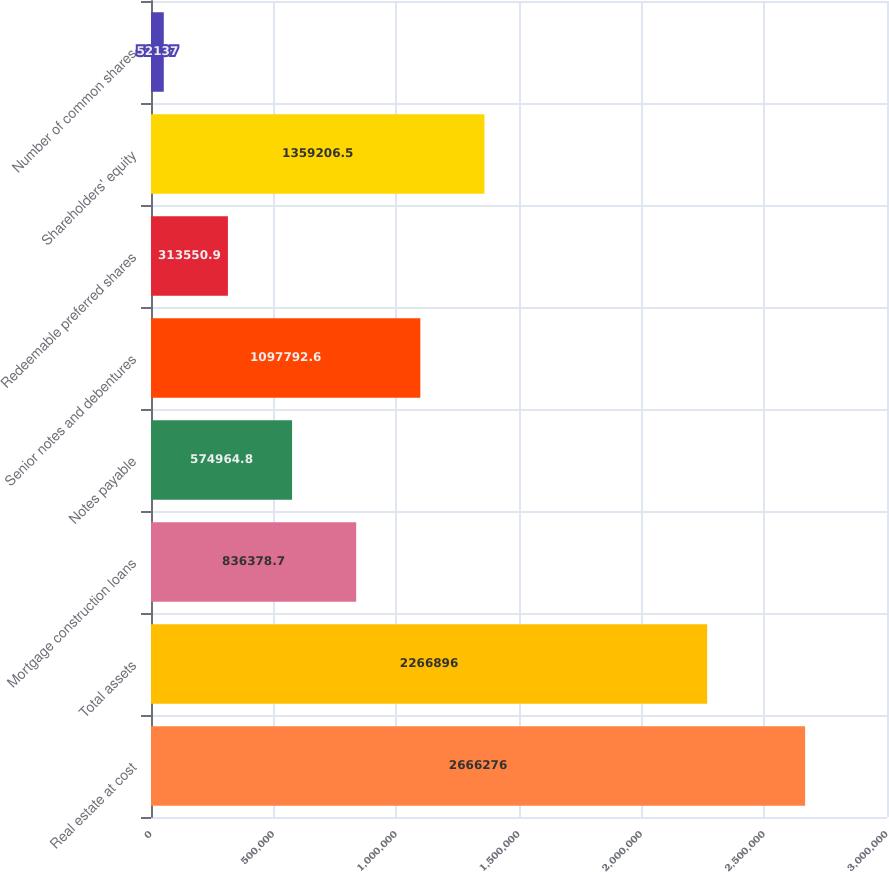Convert chart. <chart><loc_0><loc_0><loc_500><loc_500><bar_chart><fcel>Real estate at cost<fcel>Total assets<fcel>Mortgage construction loans<fcel>Notes payable<fcel>Senior notes and debentures<fcel>Redeemable preferred shares<fcel>Shareholders' equity<fcel>Number of common shares<nl><fcel>2.66628e+06<fcel>2.2669e+06<fcel>836379<fcel>574965<fcel>1.09779e+06<fcel>313551<fcel>1.35921e+06<fcel>52137<nl></chart> 